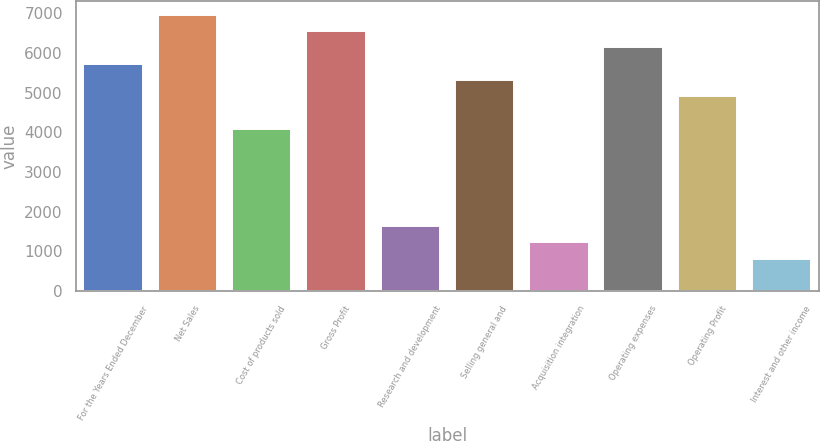Convert chart to OTSL. <chart><loc_0><loc_0><loc_500><loc_500><bar_chart><fcel>For the Years Ended December<fcel>Net Sales<fcel>Cost of products sold<fcel>Gross Profit<fcel>Research and development<fcel>Selling general and<fcel>Acquisition integration<fcel>Operating expenses<fcel>Operating Profit<fcel>Interest and other income<nl><fcel>5732.26<fcel>6959.89<fcel>4095.42<fcel>6550.68<fcel>1640.16<fcel>5323.05<fcel>1230.95<fcel>6141.47<fcel>4913.84<fcel>821.74<nl></chart> 